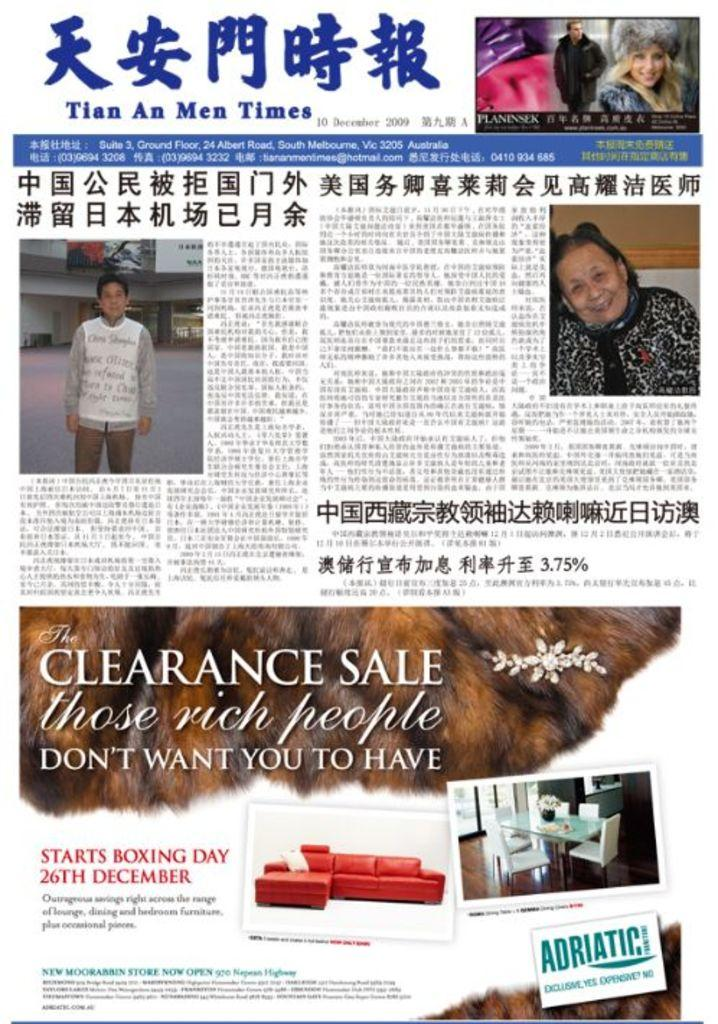What is the main object in the image? The image contains a poster. What can be found on the poster? There is text and images of persons on the poster. Can you describe the images of persons on the poster? The poster depicts a couch and a dining table. What type of vegetable is being served on the dining table in the image? There is no dining table or vegetable present in the image; it only features a poster with text and images of persons. Is the queen mentioned or depicted on the poster? There is no mention or depiction of a queen on the poster. 